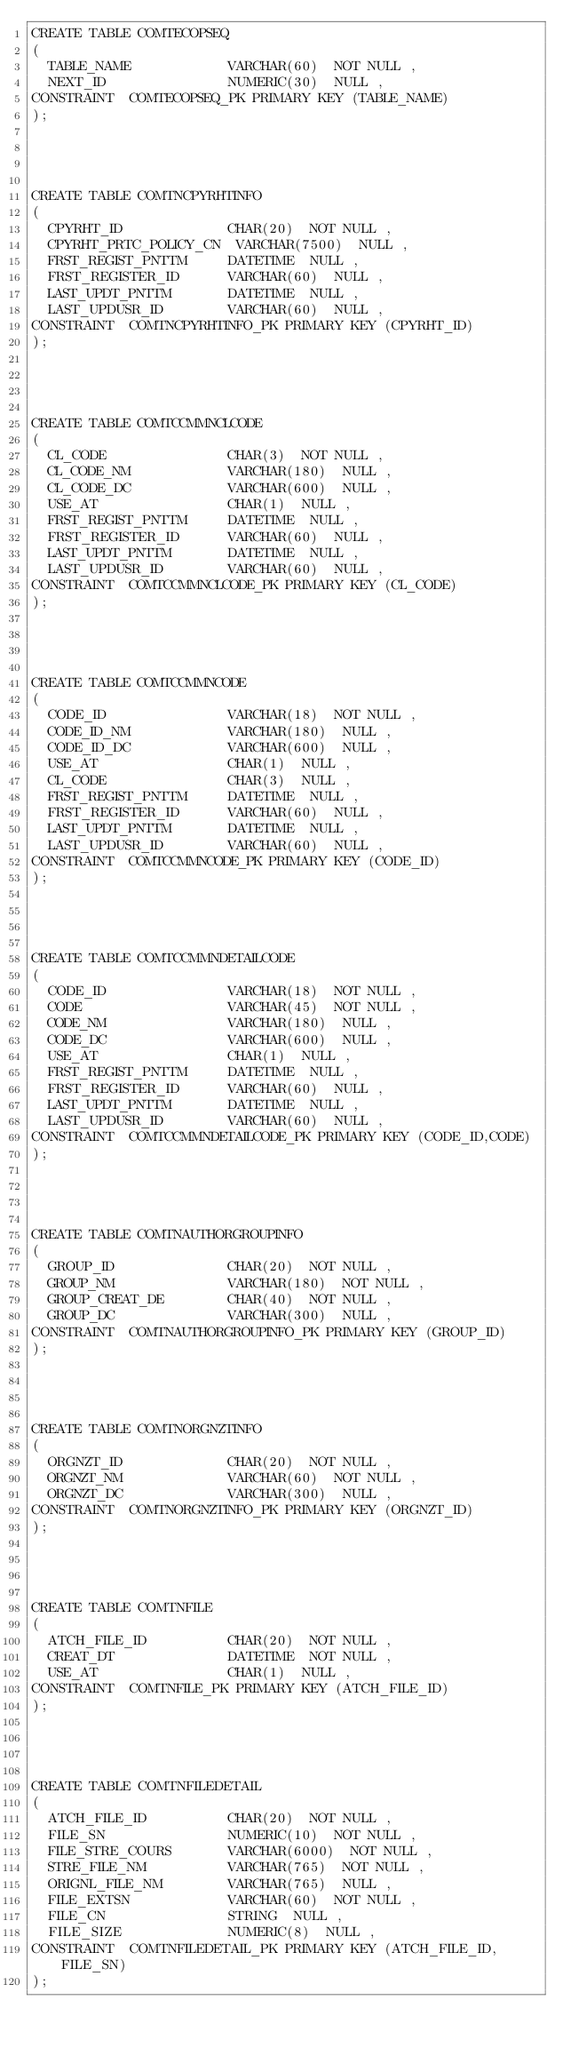Convert code to text. <code><loc_0><loc_0><loc_500><loc_500><_SQL_>CREATE TABLE COMTECOPSEQ
(
	TABLE_NAME            VARCHAR(60)  NOT NULL ,
	NEXT_ID               NUMERIC(30)  NULL ,
CONSTRAINT  COMTECOPSEQ_PK PRIMARY KEY (TABLE_NAME)
);




CREATE TABLE COMTNCPYRHTINFO
(
	CPYRHT_ID             CHAR(20)  NOT NULL ,
	CPYRHT_PRTC_POLICY_CN  VARCHAR(7500)  NULL ,
	FRST_REGIST_PNTTM     DATETIME  NULL ,
	FRST_REGISTER_ID      VARCHAR(60)  NULL ,
	LAST_UPDT_PNTTM       DATETIME  NULL ,
	LAST_UPDUSR_ID        VARCHAR(60)  NULL ,
CONSTRAINT  COMTNCPYRHTINFO_PK PRIMARY KEY (CPYRHT_ID)
);




CREATE TABLE COMTCCMMNCLCODE
(
	CL_CODE               CHAR(3)  NOT NULL ,
	CL_CODE_NM            VARCHAR(180)  NULL ,
	CL_CODE_DC            VARCHAR(600)  NULL ,
	USE_AT                CHAR(1)  NULL ,
	FRST_REGIST_PNTTM     DATETIME  NULL ,
	FRST_REGISTER_ID      VARCHAR(60)  NULL ,
	LAST_UPDT_PNTTM       DATETIME  NULL ,
	LAST_UPDUSR_ID        VARCHAR(60)  NULL ,
CONSTRAINT  COMTCCMMNCLCODE_PK PRIMARY KEY (CL_CODE)
);




CREATE TABLE COMTCCMMNCODE
(
	CODE_ID               VARCHAR(18)  NOT NULL ,
	CODE_ID_NM            VARCHAR(180)  NULL ,
	CODE_ID_DC            VARCHAR(600)  NULL ,
	USE_AT                CHAR(1)  NULL ,
	CL_CODE               CHAR(3)  NULL ,
	FRST_REGIST_PNTTM     DATETIME  NULL ,
	FRST_REGISTER_ID      VARCHAR(60)  NULL ,
	LAST_UPDT_PNTTM       DATETIME  NULL ,
	LAST_UPDUSR_ID        VARCHAR(60)  NULL ,
CONSTRAINT  COMTCCMMNCODE_PK PRIMARY KEY (CODE_ID)
);




CREATE TABLE COMTCCMMNDETAILCODE
(
	CODE_ID               VARCHAR(18)  NOT NULL ,
	CODE                  VARCHAR(45)  NOT NULL ,
	CODE_NM               VARCHAR(180)  NULL ,
	CODE_DC               VARCHAR(600)  NULL ,
	USE_AT                CHAR(1)  NULL ,
	FRST_REGIST_PNTTM     DATETIME  NULL ,
	FRST_REGISTER_ID      VARCHAR(60)  NULL ,
	LAST_UPDT_PNTTM       DATETIME  NULL ,
	LAST_UPDUSR_ID        VARCHAR(60)  NULL ,
CONSTRAINT  COMTCCMMNDETAILCODE_PK PRIMARY KEY (CODE_ID,CODE)
);




CREATE TABLE COMTNAUTHORGROUPINFO
(
	GROUP_ID              CHAR(20)  NOT NULL ,
	GROUP_NM              VARCHAR(180)  NOT NULL ,
	GROUP_CREAT_DE        CHAR(40)  NOT NULL ,
	GROUP_DC              VARCHAR(300)  NULL ,
CONSTRAINT  COMTNAUTHORGROUPINFO_PK PRIMARY KEY (GROUP_ID)
);




CREATE TABLE COMTNORGNZTINFO
(
	ORGNZT_ID             CHAR(20)  NOT NULL ,
	ORGNZT_NM             VARCHAR(60)  NOT NULL ,
	ORGNZT_DC             VARCHAR(300)  NULL ,
CONSTRAINT  COMTNORGNZTINFO_PK PRIMARY KEY (ORGNZT_ID)
);




CREATE TABLE COMTNFILE
(
	ATCH_FILE_ID          CHAR(20)  NOT NULL ,
	CREAT_DT              DATETIME  NOT NULL ,
	USE_AT                CHAR(1)  NULL ,
CONSTRAINT  COMTNFILE_PK PRIMARY KEY (ATCH_FILE_ID)
);




CREATE TABLE COMTNFILEDETAIL
(
	ATCH_FILE_ID          CHAR(20)  NOT NULL ,
	FILE_SN               NUMERIC(10)  NOT NULL ,
	FILE_STRE_COURS       VARCHAR(6000)  NOT NULL ,
	STRE_FILE_NM          VARCHAR(765)  NOT NULL ,
	ORIGNL_FILE_NM        VARCHAR(765)  NULL ,
	FILE_EXTSN            VARCHAR(60)  NOT NULL ,
	FILE_CN               STRING  NULL ,
	FILE_SIZE             NUMERIC(8)  NULL ,
CONSTRAINT  COMTNFILEDETAIL_PK PRIMARY KEY (ATCH_FILE_ID,FILE_SN)
);




</code> 